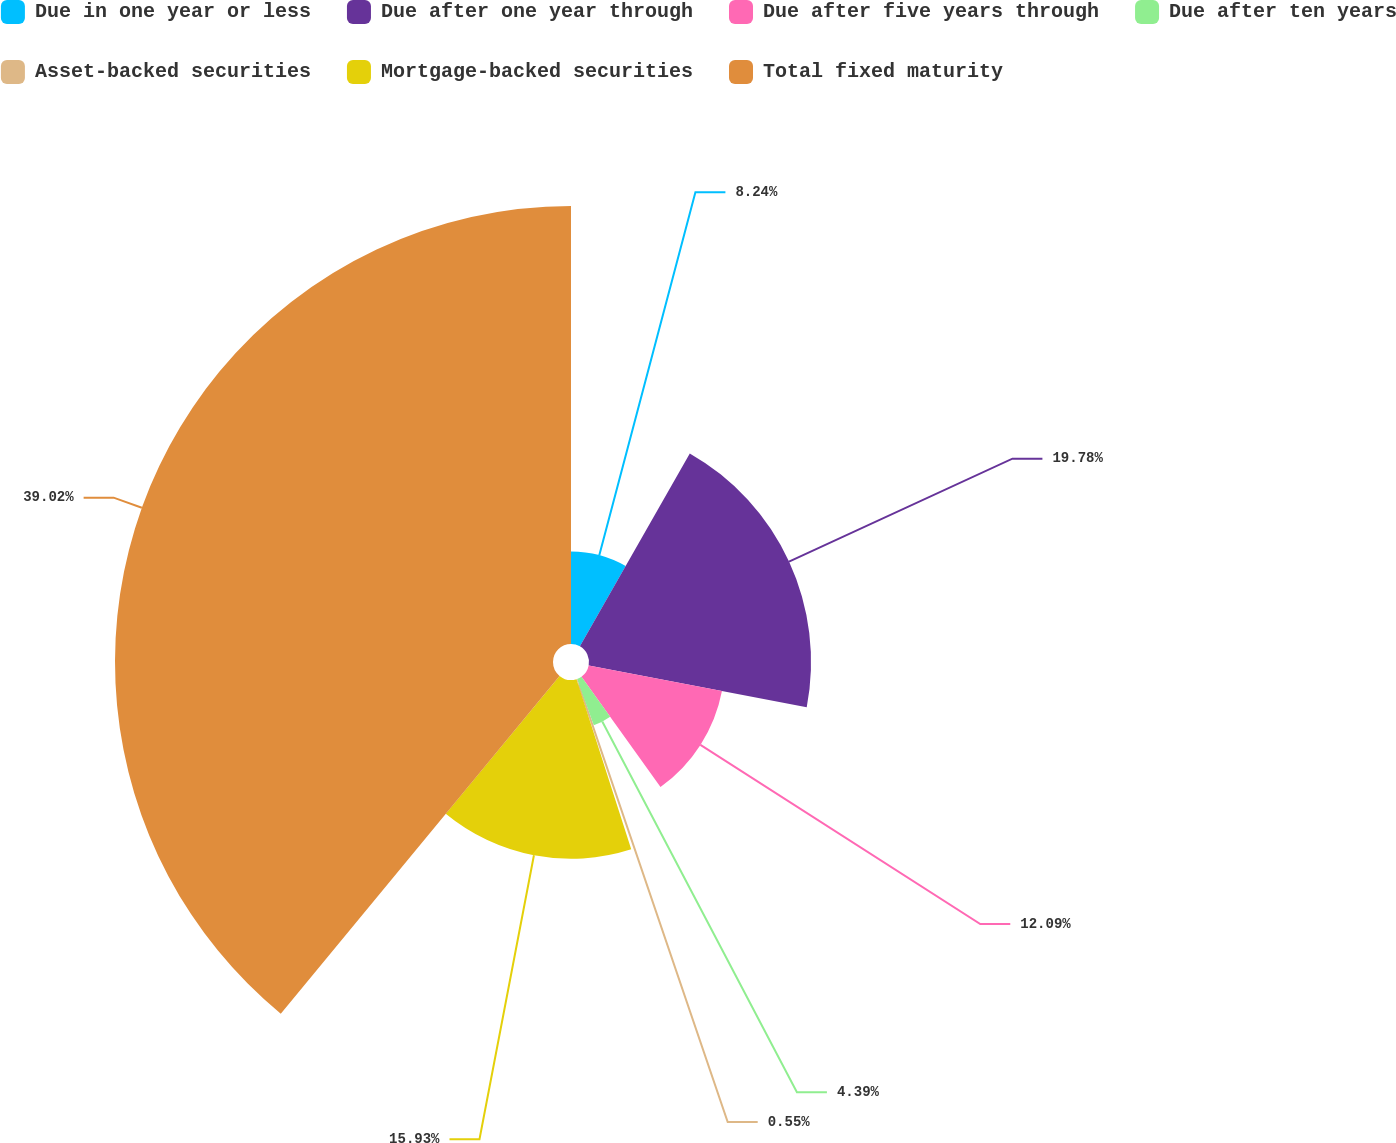Convert chart to OTSL. <chart><loc_0><loc_0><loc_500><loc_500><pie_chart><fcel>Due in one year or less<fcel>Due after one year through<fcel>Due after five years through<fcel>Due after ten years<fcel>Asset-backed securities<fcel>Mortgage-backed securities<fcel>Total fixed maturity<nl><fcel>8.24%<fcel>19.78%<fcel>12.09%<fcel>4.39%<fcel>0.55%<fcel>15.93%<fcel>39.02%<nl></chart> 